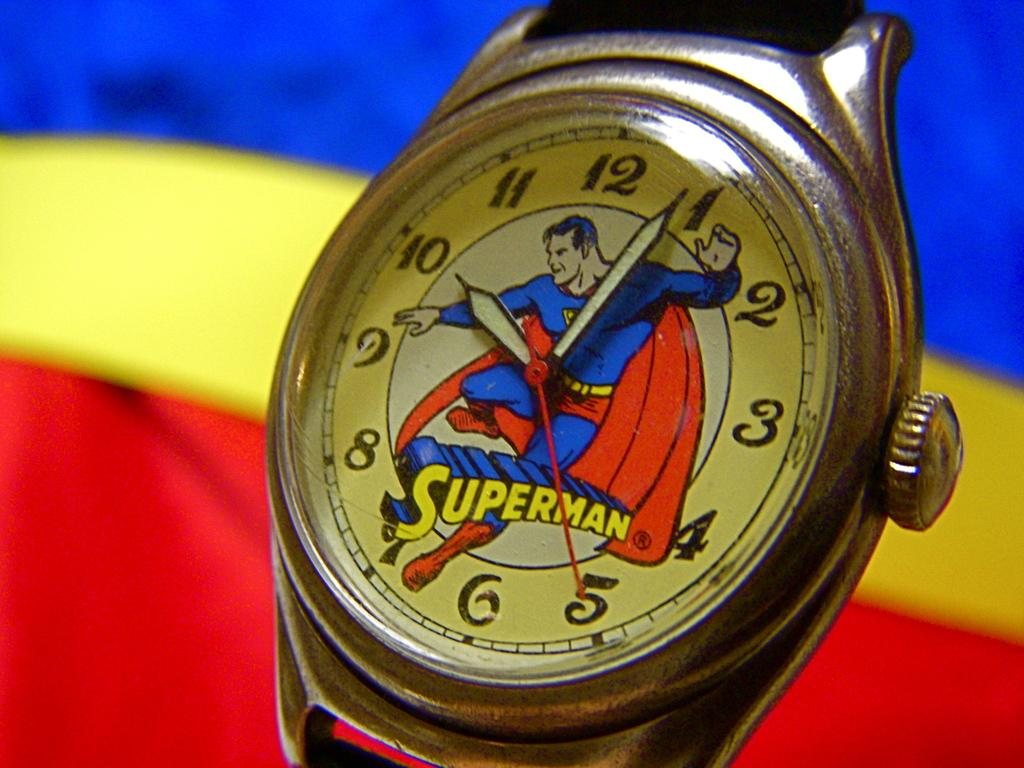What is the main subject of the image? The main subject of the image is a wrist watch dial. What is depicted on the dial? The dial has a Superman image. What colors are present in the background of the dial? The background of the dial has blue, red, and yellow colors. How many flowers are present on the wrist watch dial? There are no flowers depicted on the wrist watch dial; it features a Superman image. What type of knife is shown next to the wrist watch dial? There is no knife present in the image; it only features the wrist watch dial with a Superman image and the background colors. 